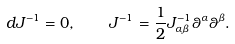Convert formula to latex. <formula><loc_0><loc_0><loc_500><loc_500>d J ^ { - 1 } = 0 , \quad J ^ { - 1 } = \frac { 1 } { 2 } J ^ { - 1 } _ { \alpha \beta } \theta ^ { \alpha } \theta ^ { \beta } .</formula> 